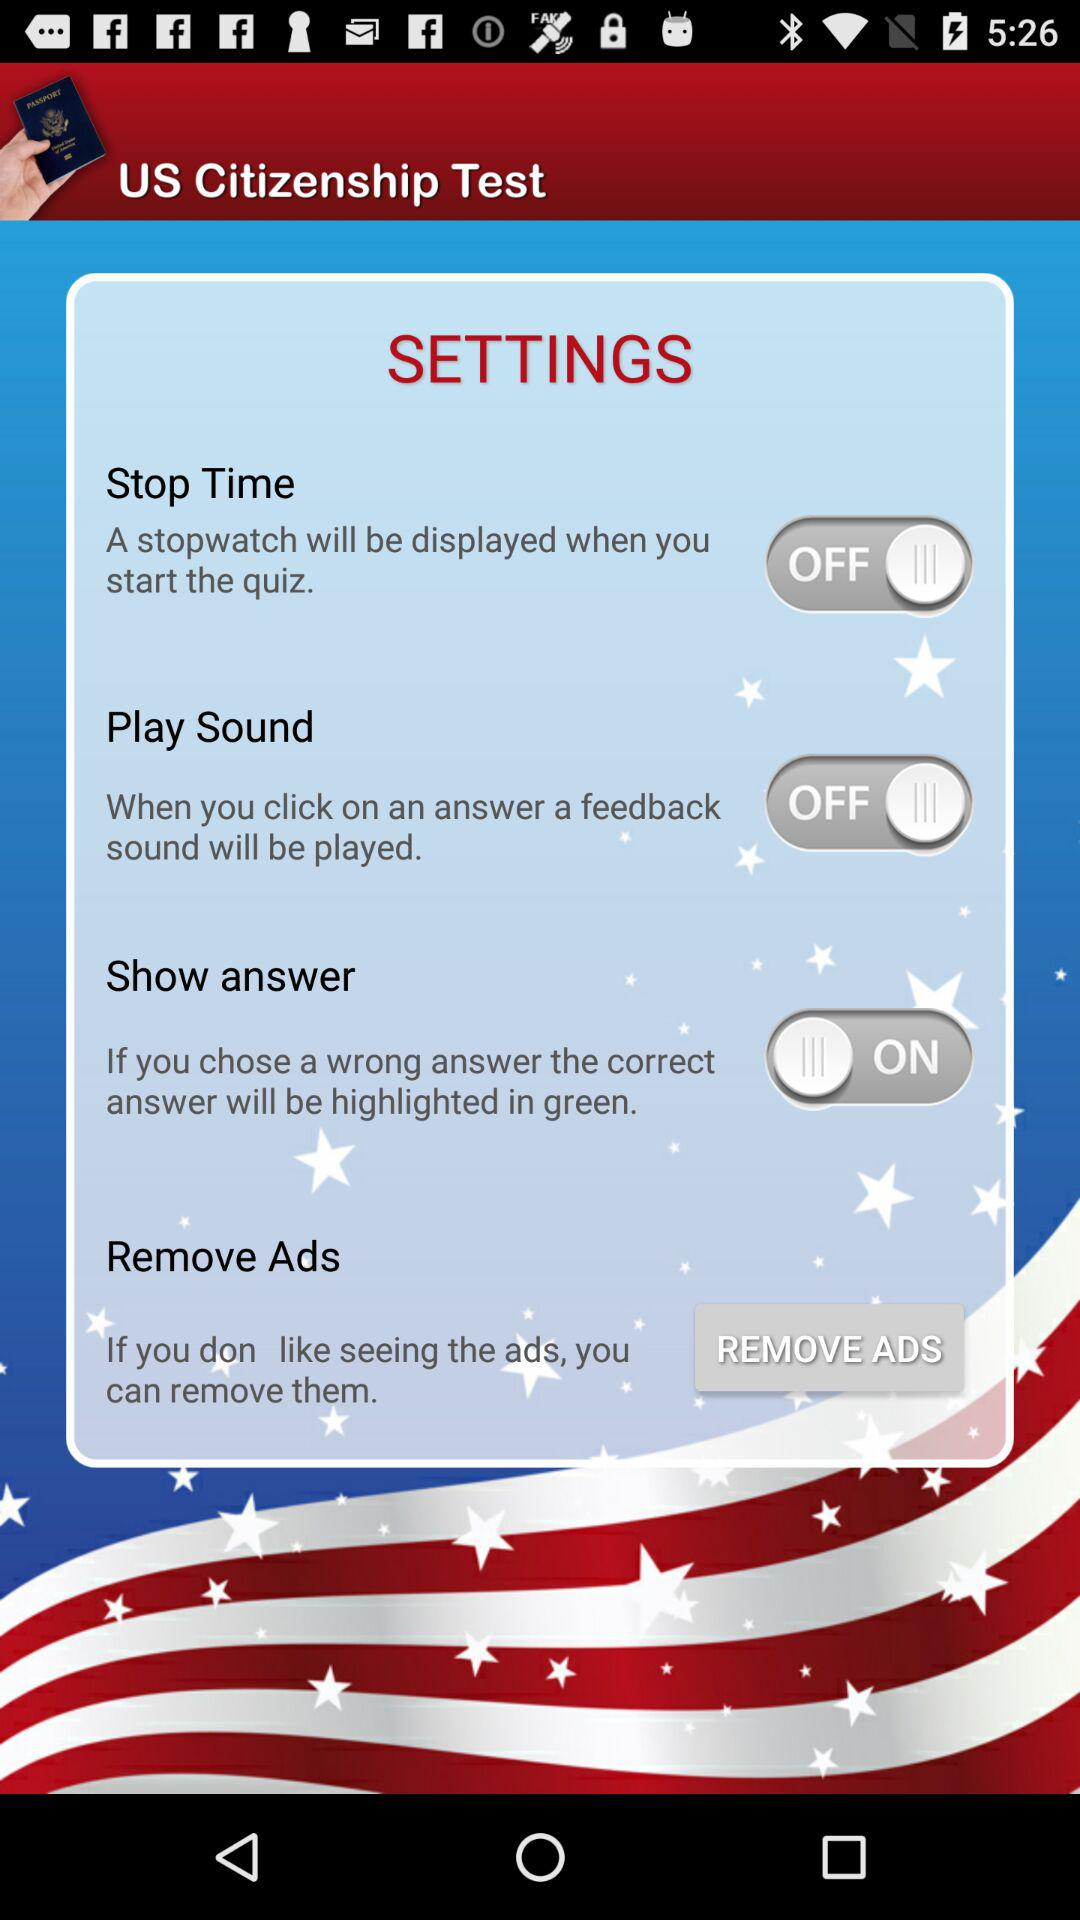What is the setting status of "Play Sound"? The status is "off". 